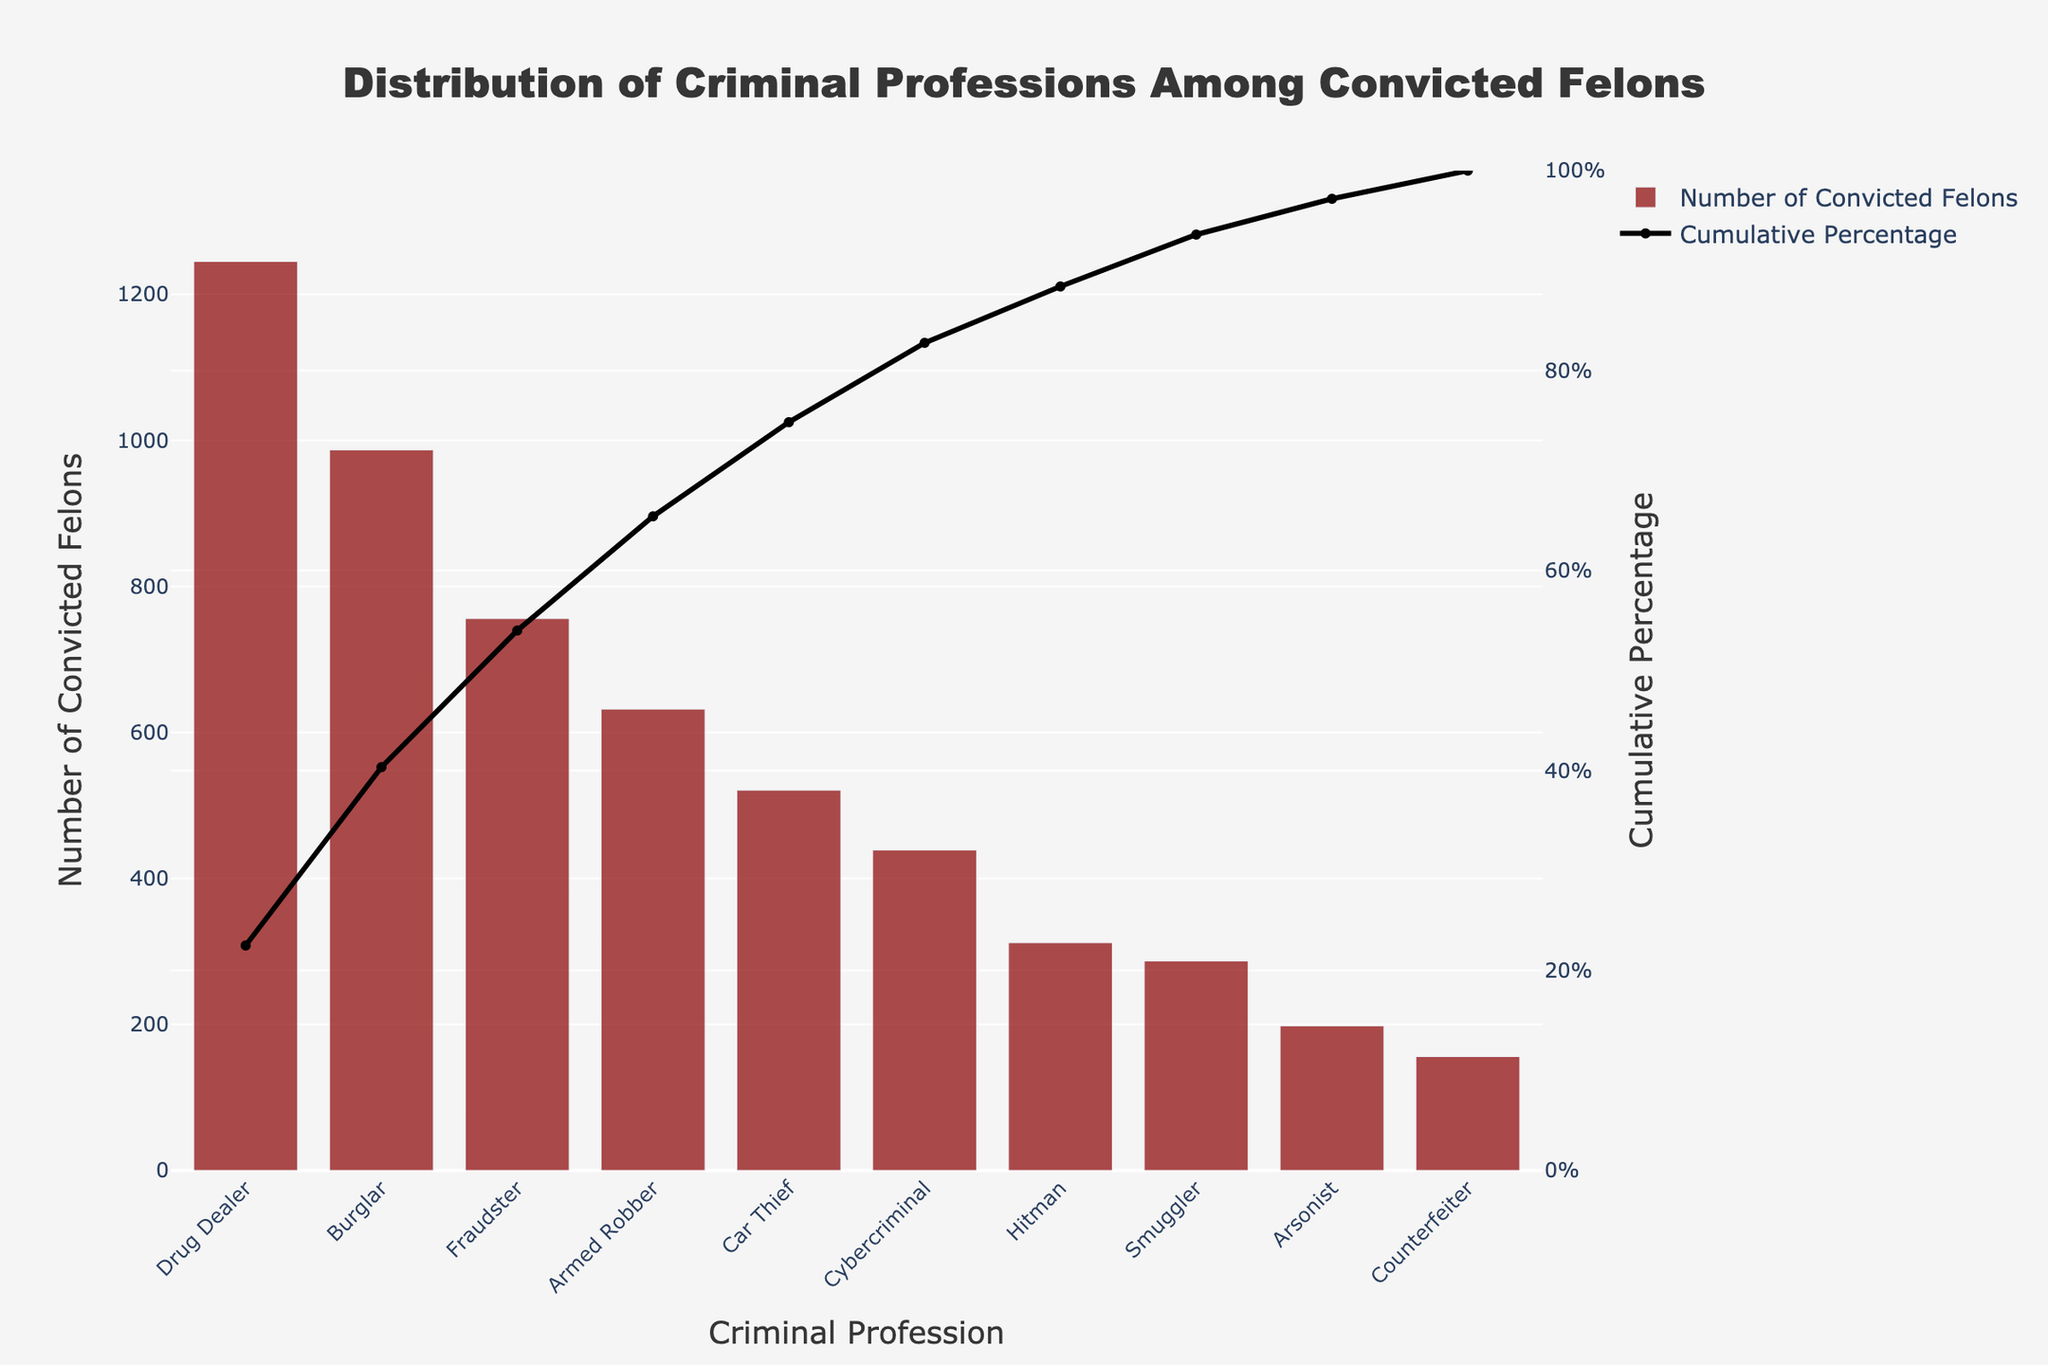What's the title of the chart? The title is located at the top center of the chart. It reads "Distribution of Criminal Professions Among Convicted Felons".
Answer: Distribution of Criminal Professions Among Convicted Felons Which criminal profession has the highest number of convicted felons? By observing the height of each bar, the first bar representing the highest value corresponds to "Drug Dealer".
Answer: Drug Dealer What is the cumulative percentage of convicted felons for the top three criminal professions? From the cumulative percentage line, sum the percentages for the top three bars: Drug Dealer (approx. 29%), Burglar (approx. 52%), and Fraudster (approx. 69%).
Answer: Approximately 69% How many criminal professions have a number of convicted felons greater than 500? Count the bars with values above the 500 mark on the y-axis: Drug Dealer, Burglar, Fraudster, Armed Robber, and Car Thief (5 professions).
Answer: 5 What's the combined number of convicted felons for Cybercriminals, Hitmen, and Smugglers? Add the y-values of these bars: Cybercriminal (439), Hitman (312), Smuggler (287). The total is 439 + 312 + 287 = 1038.
Answer: 1038 Which criminal profession contributes the least to the number of convicted felons? The shortest bar represents "Counterfeiter" as it's the final bar in the sorted order.
Answer: Counterfeiter What is the cumulative percentage contribution of Car Thieves? Locate the Car Thief position and corresponding cumulative percentage (approx. 85%) from the cumulative percentage line graph.
Answer: Approximately 85% How does the number of convicted Burglars compare to Fraudsters? The height of the Burglar bar is higher than that of the Fraudster, indicating more convicted Burglars.
Answer: More At which criminal profession does the cumulative percentage cross the 50% mark? Refer to the cumulative percentage line; it crosses the 50% threshold between Burglar (approx. 52%).
Answer: Burglar Which profession sits exactly in the middle of the cumulative percentage chart? Calculate the median profession in a descending sorted list. With 10 items, the average of the 5th and 6th positions (Car Thief and Cybercriminal) will be in the middle.
Answer: Car Thief 